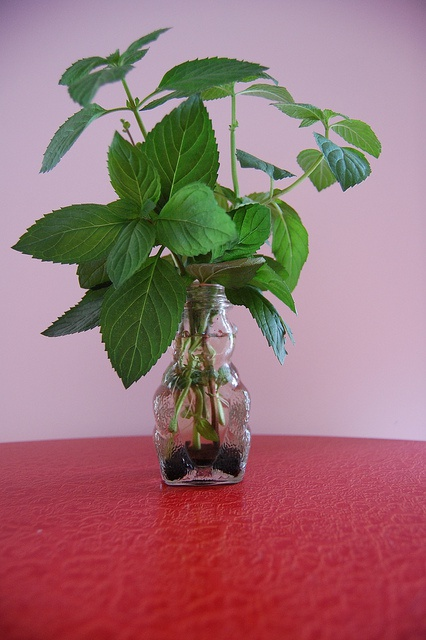Describe the objects in this image and their specific colors. I can see potted plant in gray, darkgreen, and black tones and vase in gray, black, brown, and darkgray tones in this image. 